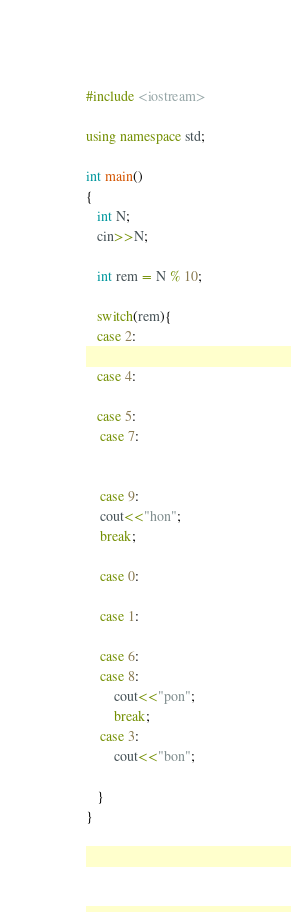<code> <loc_0><loc_0><loc_500><loc_500><_C++_>#include <iostream>

using namespace std;

int main()
{
   int N;
   cin>>N;

   int rem = N % 10;

   switch(rem){
   case 2:

   case 4:

   case 5:
    case 7:


    case 9:
    cout<<"hon";
    break;

    case 0:

    case 1:

    case 6:
    case 8:
        cout<<"pon";
        break;
    case 3:
        cout<<"bon";

   }
}
</code> 